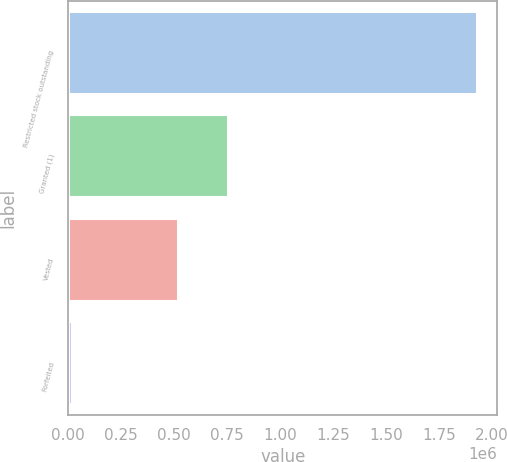<chart> <loc_0><loc_0><loc_500><loc_500><bar_chart><fcel>Restricted stock outstanding<fcel>Granted (1)<fcel>Vested<fcel>Forfeited<nl><fcel>1.93073e+06<fcel>756530<fcel>520539<fcel>17793<nl></chart> 